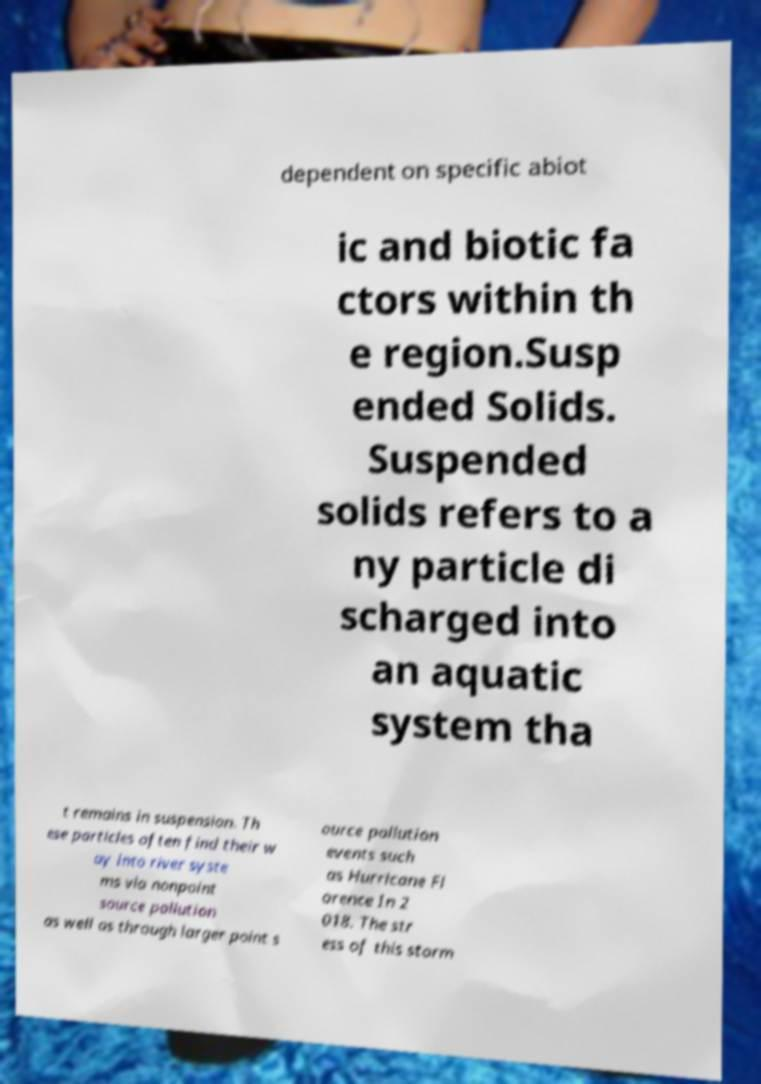There's text embedded in this image that I need extracted. Can you transcribe it verbatim? dependent on specific abiot ic and biotic fa ctors within th e region.Susp ended Solids. Suspended solids refers to a ny particle di scharged into an aquatic system tha t remains in suspension. Th ese particles often find their w ay into river syste ms via nonpoint source pollution as well as through larger point s ource pollution events such as Hurricane Fl orence In 2 018. The str ess of this storm 